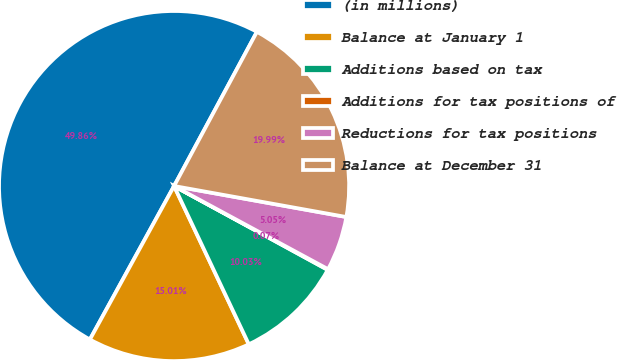Convert chart to OTSL. <chart><loc_0><loc_0><loc_500><loc_500><pie_chart><fcel>(in millions)<fcel>Balance at January 1<fcel>Additions based on tax<fcel>Additions for tax positions of<fcel>Reductions for tax positions<fcel>Balance at December 31<nl><fcel>49.87%<fcel>15.01%<fcel>10.03%<fcel>0.07%<fcel>5.05%<fcel>19.99%<nl></chart> 